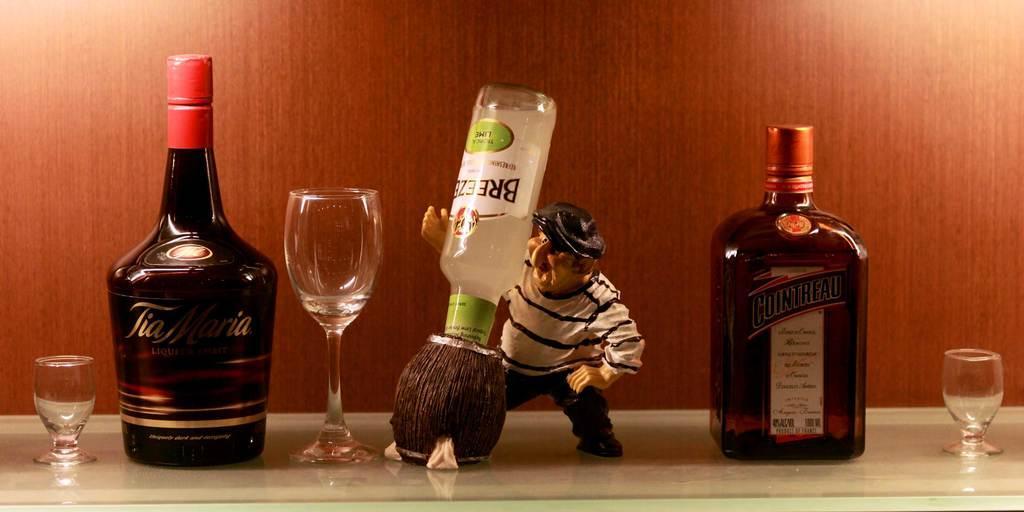Can you describe this image briefly? In the given image we can see bottle, wine glass and a person wearing a cap. This is a toy. 